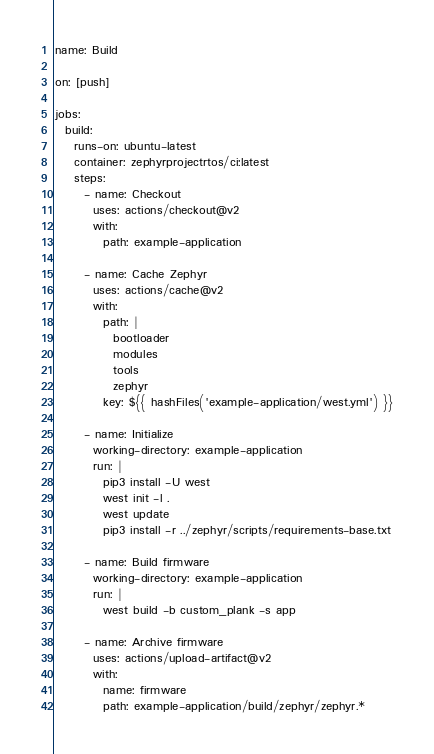<code> <loc_0><loc_0><loc_500><loc_500><_YAML_>name: Build

on: [push]

jobs:
  build:
    runs-on: ubuntu-latest
    container: zephyrprojectrtos/ci:latest
    steps:
      - name: Checkout
        uses: actions/checkout@v2
        with:
          path: example-application

      - name: Cache Zephyr
        uses: actions/cache@v2
        with:
          path: |
            bootloader
            modules
            tools
            zephyr
          key: ${{ hashFiles('example-application/west.yml') }}

      - name: Initialize
        working-directory: example-application
        run: |
          pip3 install -U west
          west init -l .
          west update
          pip3 install -r ../zephyr/scripts/requirements-base.txt

      - name: Build firmware
        working-directory: example-application
        run: |
          west build -b custom_plank -s app

      - name: Archive firmware
        uses: actions/upload-artifact@v2
        with:
          name: firmware
          path: example-application/build/zephyr/zephyr.*
</code> 